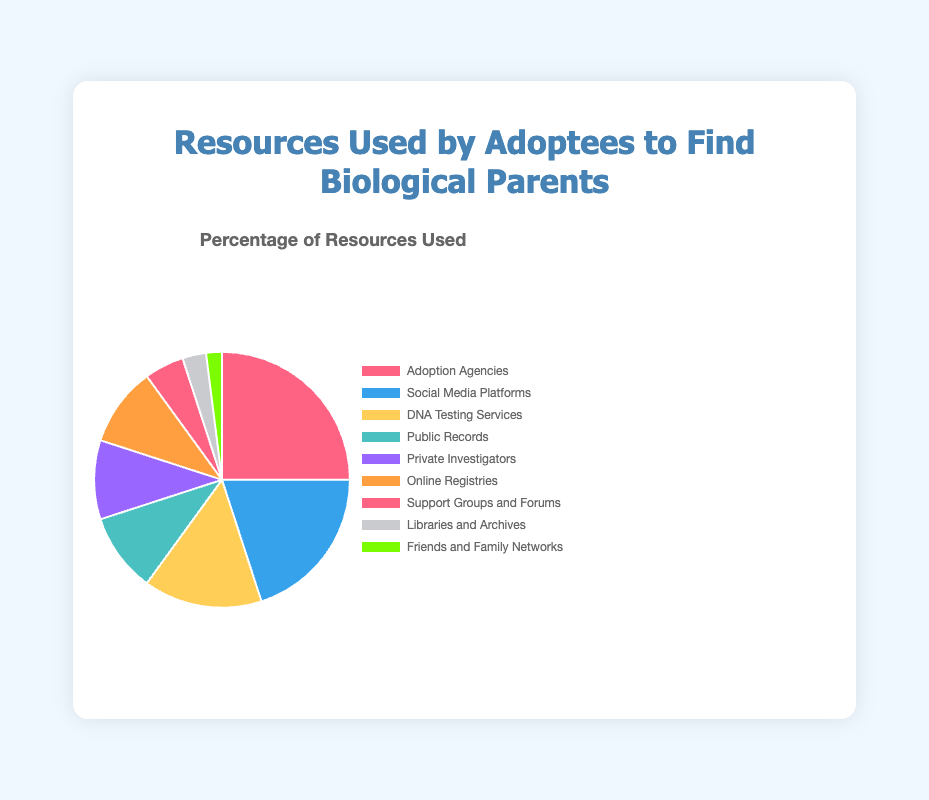What's the most used resource by adoptees to find their biological parents? The pie chart indicates the different resources used by adoptees along with their percentages. Adoption Agencies have the highest percentage at 25%, making it the most used resource.
Answer: Adoption Agencies What percentage of adoptees use DNA Testing Services? Inspecting the pie chart, DNA Testing Services are represented and marked with their percentage. The chart shows that 15% of adoptees use DNA Testing Services.
Answer: 15% Which resource is used equally by 10% of adoptees? Observing the pie chart, we see that both Public Records and Private Investigators are indicated to be used by 10% of adoptees each.
Answer: Public Records and Private Investigators What is the total percentage of adoptees using Social Media Platforms and Online Registries combined? The chart specifies that Social Media Platforms are used by 20% and Online Registries by 10%. Adding these percentages gives 20% + 10% = 30%.
Answer: 30% Which resources are used by fewer adoptees than Support Groups and Forums? Support Groups and Forums are represented by 5%. Comparing other percentages, Friends and Family Networks (2%) and Libraries and Archives (3%) are both lower.
Answer: Friends and Family Networks and Libraries and Archives What colors represent Adoption Agencies and DNA Testing Services? The pie chart uses distinct colors for each segment. Adoption Agencies are represented by red, and DNA Testing Services are represented by yellow.
Answer: Red and Yellow How much more popular are Adoption Agencies compared to Private Investigators? Adoption Agencies are used by 25% of adoptees, whereas Private Investigators are used by 10%. The difference is 25% - 10% = 15%.
Answer: 15% What is the total percentage of adoptees who use less popular resources (those under 10%)? The resources under 10% are Support Groups and Forums (5%), Libraries and Archives (3%), and Friends and Family Networks (2%). Adding these gives 5% + 3% + 2% = 10%.
Answer: 10% 